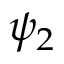<formula> <loc_0><loc_0><loc_500><loc_500>\psi _ { 2 }</formula> 